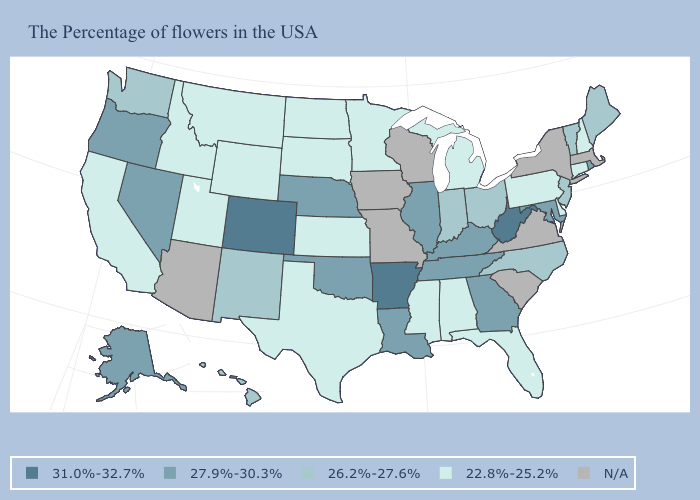Among the states that border South Carolina , which have the lowest value?
Answer briefly. North Carolina. What is the lowest value in the South?
Concise answer only. 22.8%-25.2%. Name the states that have a value in the range 26.2%-27.6%?
Give a very brief answer. Maine, Vermont, New Jersey, North Carolina, Ohio, Indiana, New Mexico, Washington, Hawaii. What is the value of Colorado?
Concise answer only. 31.0%-32.7%. What is the lowest value in states that border South Carolina?
Concise answer only. 26.2%-27.6%. Which states hav the highest value in the MidWest?
Give a very brief answer. Illinois, Nebraska. Does Montana have the highest value in the West?
Be succinct. No. Is the legend a continuous bar?
Give a very brief answer. No. Does the map have missing data?
Keep it brief. Yes. Name the states that have a value in the range 27.9%-30.3%?
Give a very brief answer. Rhode Island, Maryland, Georgia, Kentucky, Tennessee, Illinois, Louisiana, Nebraska, Oklahoma, Nevada, Oregon, Alaska. Is the legend a continuous bar?
Answer briefly. No. Does the first symbol in the legend represent the smallest category?
Keep it brief. No. Which states have the lowest value in the USA?
Keep it brief. New Hampshire, Connecticut, Delaware, Pennsylvania, Florida, Michigan, Alabama, Mississippi, Minnesota, Kansas, Texas, South Dakota, North Dakota, Wyoming, Utah, Montana, Idaho, California. Name the states that have a value in the range 31.0%-32.7%?
Write a very short answer. West Virginia, Arkansas, Colorado. Which states have the highest value in the USA?
Give a very brief answer. West Virginia, Arkansas, Colorado. 